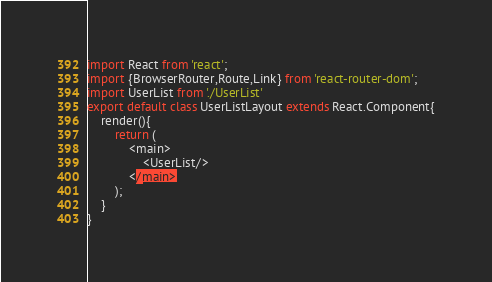<code> <loc_0><loc_0><loc_500><loc_500><_JavaScript_>import React from 'react';
import {BrowserRouter,Route,Link} from 'react-router-dom';
import UserList from './UserList'
export default class UserListLayout extends React.Component{
    render(){
        return (
            <main>
                <UserList/>
            </main>
        );
    }
}</code> 